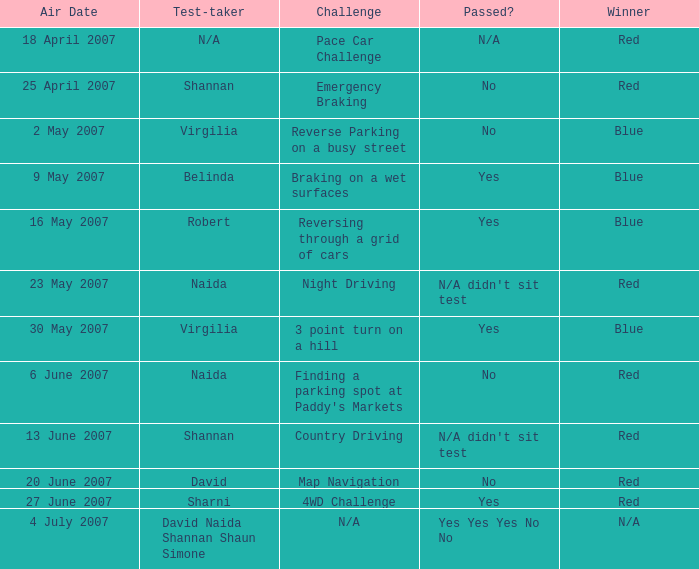What air date has a red winner and an emergency braking challenge? 25 April 2007. 